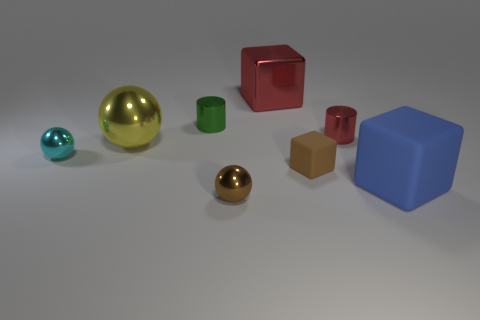Is the number of small brown metal objects that are to the right of the small brown shiny thing less than the number of tiny green things?
Provide a succinct answer. Yes. Is there another thing that has the same shape as the small green thing?
Keep it short and to the point. Yes. What shape is the cyan metallic thing that is the same size as the brown cube?
Keep it short and to the point. Sphere. What number of things are brown objects or tiny yellow metal blocks?
Provide a short and direct response. 2. Are any green things visible?
Ensure brevity in your answer.  Yes. Is the number of brown rubber things less than the number of rubber spheres?
Offer a terse response. No. Is there a red metallic thing of the same size as the green thing?
Give a very brief answer. Yes. There is a large yellow shiny object; is its shape the same as the small metallic object in front of the cyan thing?
Ensure brevity in your answer.  Yes. What number of balls are large objects or brown rubber objects?
Keep it short and to the point. 1. What color is the big metal block?
Keep it short and to the point. Red. 